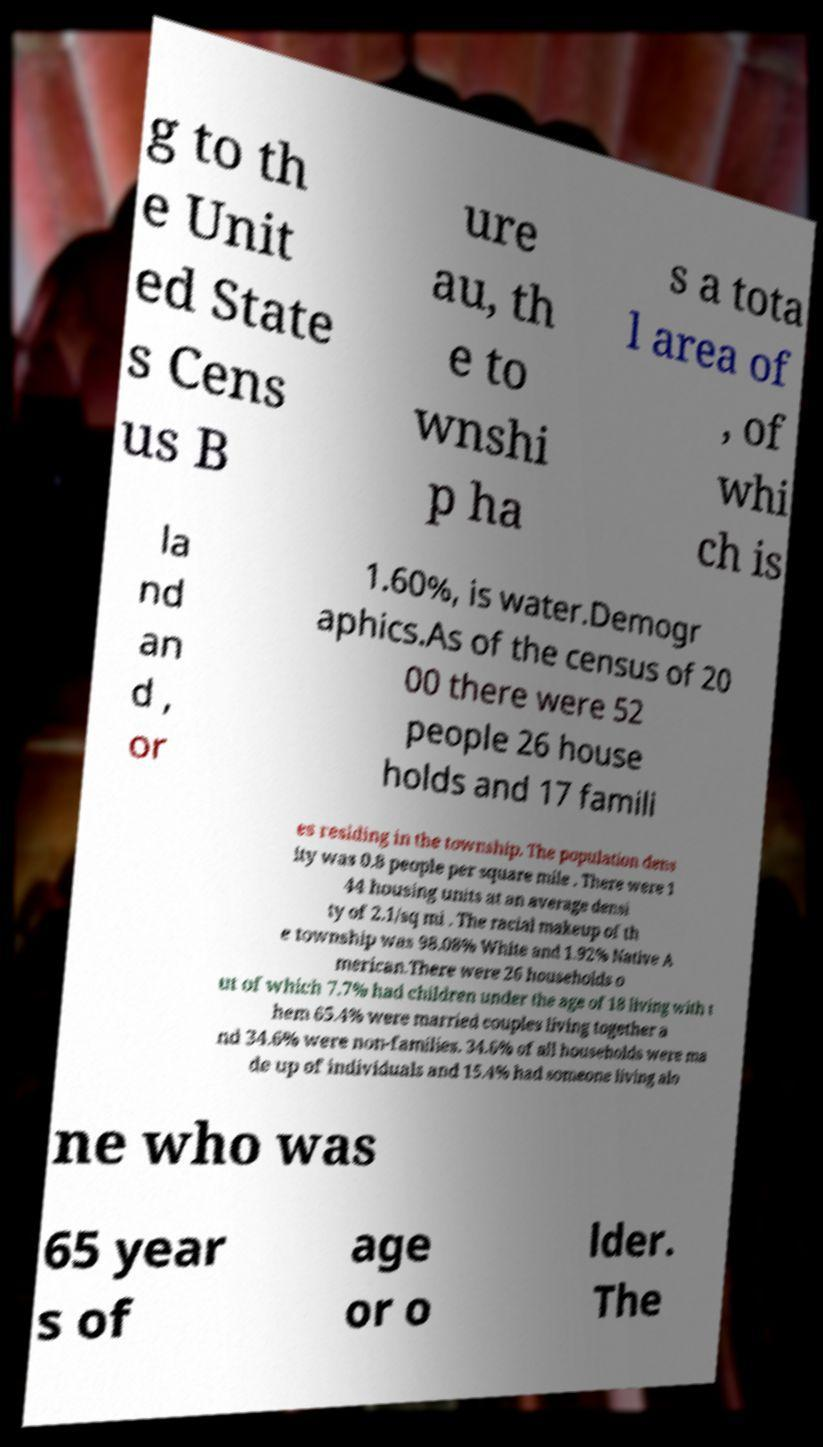Please identify and transcribe the text found in this image. g to th e Unit ed State s Cens us B ure au, th e to wnshi p ha s a tota l area of , of whi ch is la nd an d , or 1.60%, is water.Demogr aphics.As of the census of 20 00 there were 52 people 26 house holds and 17 famili es residing in the township. The population dens ity was 0.8 people per square mile . There were 1 44 housing units at an average densi ty of 2.1/sq mi . The racial makeup of th e township was 98.08% White and 1.92% Native A merican.There were 26 households o ut of which 7.7% had children under the age of 18 living with t hem 65.4% were married couples living together a nd 34.6% were non-families. 34.6% of all households were ma de up of individuals and 15.4% had someone living alo ne who was 65 year s of age or o lder. The 